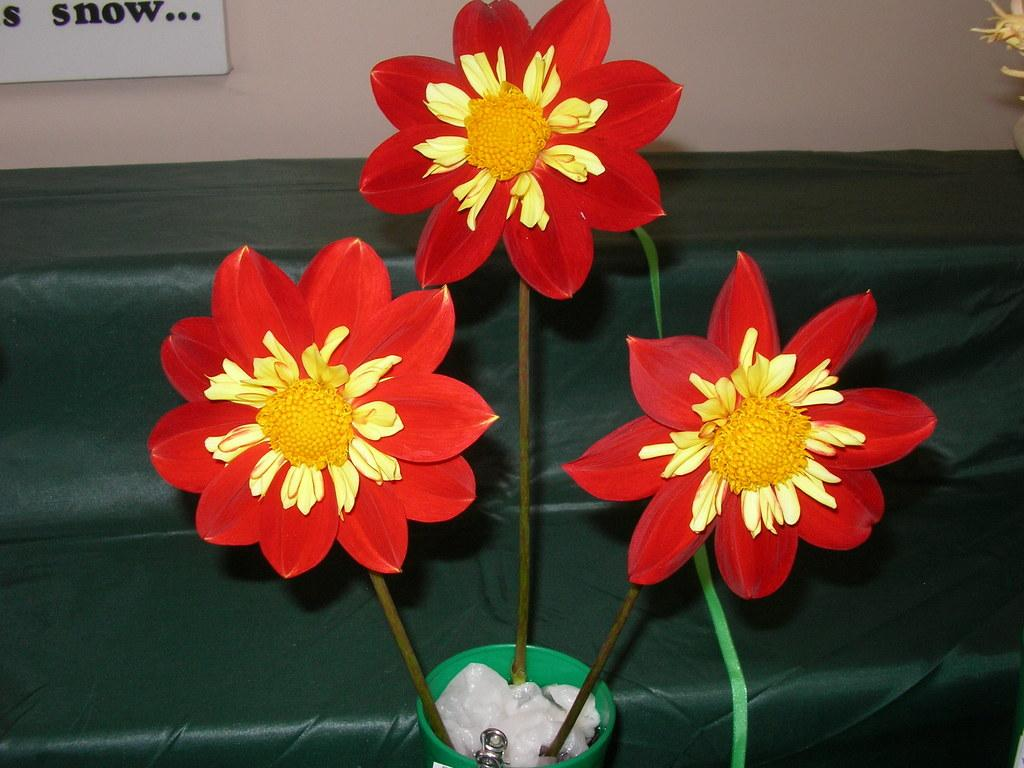What type of plant is in the pot in the image? There are flowers in a pot in the image. What else can be seen in the image besides the flowers? There are papers visible in the image. What can be seen in the background of the image? There is a cloth and a board on the wall in the background of the image. Can you tell me what type of frame is around the flowers in the image? There is no frame around the flowers in the image; it is a pot containing flowers. 